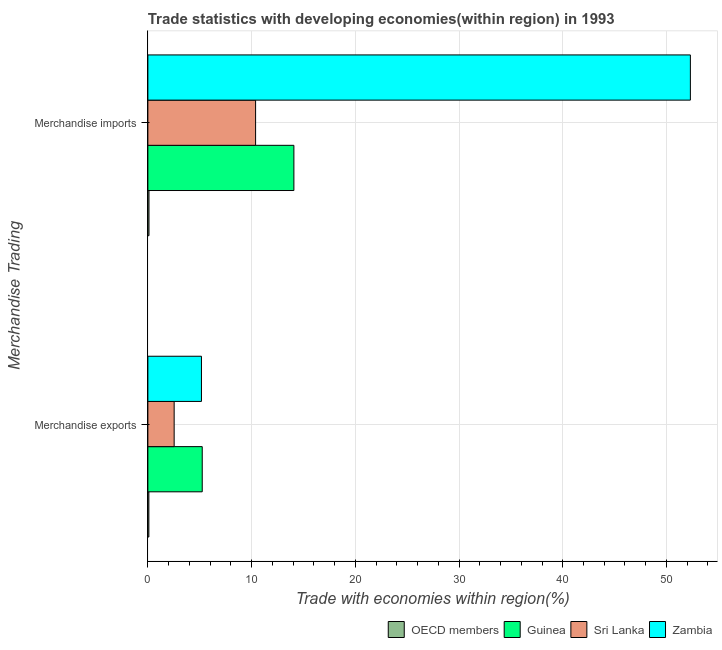How many different coloured bars are there?
Keep it short and to the point. 4. How many groups of bars are there?
Your answer should be compact. 2. Are the number of bars per tick equal to the number of legend labels?
Give a very brief answer. Yes. How many bars are there on the 1st tick from the top?
Offer a terse response. 4. What is the label of the 2nd group of bars from the top?
Offer a terse response. Merchandise exports. What is the merchandise exports in OECD members?
Offer a terse response. 0.1. Across all countries, what is the maximum merchandise exports?
Your answer should be compact. 5.24. Across all countries, what is the minimum merchandise imports?
Offer a terse response. 0.11. In which country was the merchandise exports maximum?
Your response must be concise. Guinea. In which country was the merchandise imports minimum?
Provide a succinct answer. OECD members. What is the total merchandise imports in the graph?
Your response must be concise. 76.88. What is the difference between the merchandise exports in Zambia and that in Sri Lanka?
Your answer should be compact. 2.63. What is the difference between the merchandise exports in OECD members and the merchandise imports in Zambia?
Your answer should be very brief. -52.21. What is the average merchandise exports per country?
Provide a short and direct response. 3.26. What is the difference between the merchandise imports and merchandise exports in Guinea?
Your response must be concise. 8.84. What is the ratio of the merchandise exports in OECD members to that in Guinea?
Your answer should be very brief. 0.02. What does the 2nd bar from the bottom in Merchandise exports represents?
Your answer should be compact. Guinea. How many bars are there?
Provide a succinct answer. 8. What is the difference between two consecutive major ticks on the X-axis?
Ensure brevity in your answer.  10. Does the graph contain any zero values?
Offer a very short reply. No. Where does the legend appear in the graph?
Your answer should be very brief. Bottom right. How many legend labels are there?
Offer a terse response. 4. How are the legend labels stacked?
Make the answer very short. Horizontal. What is the title of the graph?
Provide a short and direct response. Trade statistics with developing economies(within region) in 1993. Does "Netherlands" appear as one of the legend labels in the graph?
Ensure brevity in your answer.  No. What is the label or title of the X-axis?
Make the answer very short. Trade with economies within region(%). What is the label or title of the Y-axis?
Provide a short and direct response. Merchandise Trading. What is the Trade with economies within region(%) of OECD members in Merchandise exports?
Your answer should be compact. 0.1. What is the Trade with economies within region(%) of Guinea in Merchandise exports?
Provide a succinct answer. 5.24. What is the Trade with economies within region(%) of Sri Lanka in Merchandise exports?
Offer a very short reply. 2.53. What is the Trade with economies within region(%) of Zambia in Merchandise exports?
Offer a terse response. 5.17. What is the Trade with economies within region(%) of OECD members in Merchandise imports?
Make the answer very short. 0.11. What is the Trade with economies within region(%) in Guinea in Merchandise imports?
Your answer should be compact. 14.08. What is the Trade with economies within region(%) of Sri Lanka in Merchandise imports?
Make the answer very short. 10.39. What is the Trade with economies within region(%) of Zambia in Merchandise imports?
Your response must be concise. 52.3. Across all Merchandise Trading, what is the maximum Trade with economies within region(%) of OECD members?
Ensure brevity in your answer.  0.11. Across all Merchandise Trading, what is the maximum Trade with economies within region(%) in Guinea?
Ensure brevity in your answer.  14.08. Across all Merchandise Trading, what is the maximum Trade with economies within region(%) of Sri Lanka?
Make the answer very short. 10.39. Across all Merchandise Trading, what is the maximum Trade with economies within region(%) of Zambia?
Provide a short and direct response. 52.3. Across all Merchandise Trading, what is the minimum Trade with economies within region(%) in OECD members?
Make the answer very short. 0.1. Across all Merchandise Trading, what is the minimum Trade with economies within region(%) of Guinea?
Your answer should be very brief. 5.24. Across all Merchandise Trading, what is the minimum Trade with economies within region(%) in Sri Lanka?
Provide a short and direct response. 2.53. Across all Merchandise Trading, what is the minimum Trade with economies within region(%) in Zambia?
Offer a terse response. 5.17. What is the total Trade with economies within region(%) of OECD members in the graph?
Offer a terse response. 0.2. What is the total Trade with economies within region(%) of Guinea in the graph?
Provide a short and direct response. 19.32. What is the total Trade with economies within region(%) of Sri Lanka in the graph?
Provide a short and direct response. 12.92. What is the total Trade with economies within region(%) of Zambia in the graph?
Ensure brevity in your answer.  57.47. What is the difference between the Trade with economies within region(%) of OECD members in Merchandise exports and that in Merchandise imports?
Keep it short and to the point. -0.01. What is the difference between the Trade with economies within region(%) in Guinea in Merchandise exports and that in Merchandise imports?
Provide a short and direct response. -8.84. What is the difference between the Trade with economies within region(%) in Sri Lanka in Merchandise exports and that in Merchandise imports?
Provide a short and direct response. -7.85. What is the difference between the Trade with economies within region(%) of Zambia in Merchandise exports and that in Merchandise imports?
Provide a succinct answer. -47.14. What is the difference between the Trade with economies within region(%) in OECD members in Merchandise exports and the Trade with economies within region(%) in Guinea in Merchandise imports?
Your answer should be compact. -13.98. What is the difference between the Trade with economies within region(%) of OECD members in Merchandise exports and the Trade with economies within region(%) of Sri Lanka in Merchandise imports?
Keep it short and to the point. -10.29. What is the difference between the Trade with economies within region(%) of OECD members in Merchandise exports and the Trade with economies within region(%) of Zambia in Merchandise imports?
Make the answer very short. -52.21. What is the difference between the Trade with economies within region(%) in Guinea in Merchandise exports and the Trade with economies within region(%) in Sri Lanka in Merchandise imports?
Offer a very short reply. -5.14. What is the difference between the Trade with economies within region(%) in Guinea in Merchandise exports and the Trade with economies within region(%) in Zambia in Merchandise imports?
Your response must be concise. -47.06. What is the difference between the Trade with economies within region(%) of Sri Lanka in Merchandise exports and the Trade with economies within region(%) of Zambia in Merchandise imports?
Make the answer very short. -49.77. What is the average Trade with economies within region(%) in OECD members per Merchandise Trading?
Provide a succinct answer. 0.1. What is the average Trade with economies within region(%) of Guinea per Merchandise Trading?
Offer a terse response. 9.66. What is the average Trade with economies within region(%) in Sri Lanka per Merchandise Trading?
Provide a short and direct response. 6.46. What is the average Trade with economies within region(%) of Zambia per Merchandise Trading?
Keep it short and to the point. 28.73. What is the difference between the Trade with economies within region(%) of OECD members and Trade with economies within region(%) of Guinea in Merchandise exports?
Give a very brief answer. -5.15. What is the difference between the Trade with economies within region(%) in OECD members and Trade with economies within region(%) in Sri Lanka in Merchandise exports?
Offer a very short reply. -2.44. What is the difference between the Trade with economies within region(%) of OECD members and Trade with economies within region(%) of Zambia in Merchandise exports?
Provide a succinct answer. -5.07. What is the difference between the Trade with economies within region(%) of Guinea and Trade with economies within region(%) of Sri Lanka in Merchandise exports?
Give a very brief answer. 2.71. What is the difference between the Trade with economies within region(%) of Guinea and Trade with economies within region(%) of Zambia in Merchandise exports?
Your answer should be very brief. 0.08. What is the difference between the Trade with economies within region(%) of Sri Lanka and Trade with economies within region(%) of Zambia in Merchandise exports?
Offer a very short reply. -2.63. What is the difference between the Trade with economies within region(%) of OECD members and Trade with economies within region(%) of Guinea in Merchandise imports?
Provide a succinct answer. -13.97. What is the difference between the Trade with economies within region(%) of OECD members and Trade with economies within region(%) of Sri Lanka in Merchandise imports?
Provide a short and direct response. -10.28. What is the difference between the Trade with economies within region(%) in OECD members and Trade with economies within region(%) in Zambia in Merchandise imports?
Keep it short and to the point. -52.2. What is the difference between the Trade with economies within region(%) in Guinea and Trade with economies within region(%) in Sri Lanka in Merchandise imports?
Keep it short and to the point. 3.69. What is the difference between the Trade with economies within region(%) in Guinea and Trade with economies within region(%) in Zambia in Merchandise imports?
Offer a very short reply. -38.22. What is the difference between the Trade with economies within region(%) of Sri Lanka and Trade with economies within region(%) of Zambia in Merchandise imports?
Your answer should be very brief. -41.92. What is the ratio of the Trade with economies within region(%) of OECD members in Merchandise exports to that in Merchandise imports?
Offer a terse response. 0.9. What is the ratio of the Trade with economies within region(%) in Guinea in Merchandise exports to that in Merchandise imports?
Your answer should be very brief. 0.37. What is the ratio of the Trade with economies within region(%) of Sri Lanka in Merchandise exports to that in Merchandise imports?
Keep it short and to the point. 0.24. What is the ratio of the Trade with economies within region(%) of Zambia in Merchandise exports to that in Merchandise imports?
Offer a terse response. 0.1. What is the difference between the highest and the second highest Trade with economies within region(%) of OECD members?
Keep it short and to the point. 0.01. What is the difference between the highest and the second highest Trade with economies within region(%) in Guinea?
Your response must be concise. 8.84. What is the difference between the highest and the second highest Trade with economies within region(%) in Sri Lanka?
Give a very brief answer. 7.85. What is the difference between the highest and the second highest Trade with economies within region(%) of Zambia?
Give a very brief answer. 47.14. What is the difference between the highest and the lowest Trade with economies within region(%) of OECD members?
Make the answer very short. 0.01. What is the difference between the highest and the lowest Trade with economies within region(%) in Guinea?
Make the answer very short. 8.84. What is the difference between the highest and the lowest Trade with economies within region(%) in Sri Lanka?
Give a very brief answer. 7.85. What is the difference between the highest and the lowest Trade with economies within region(%) in Zambia?
Offer a very short reply. 47.14. 